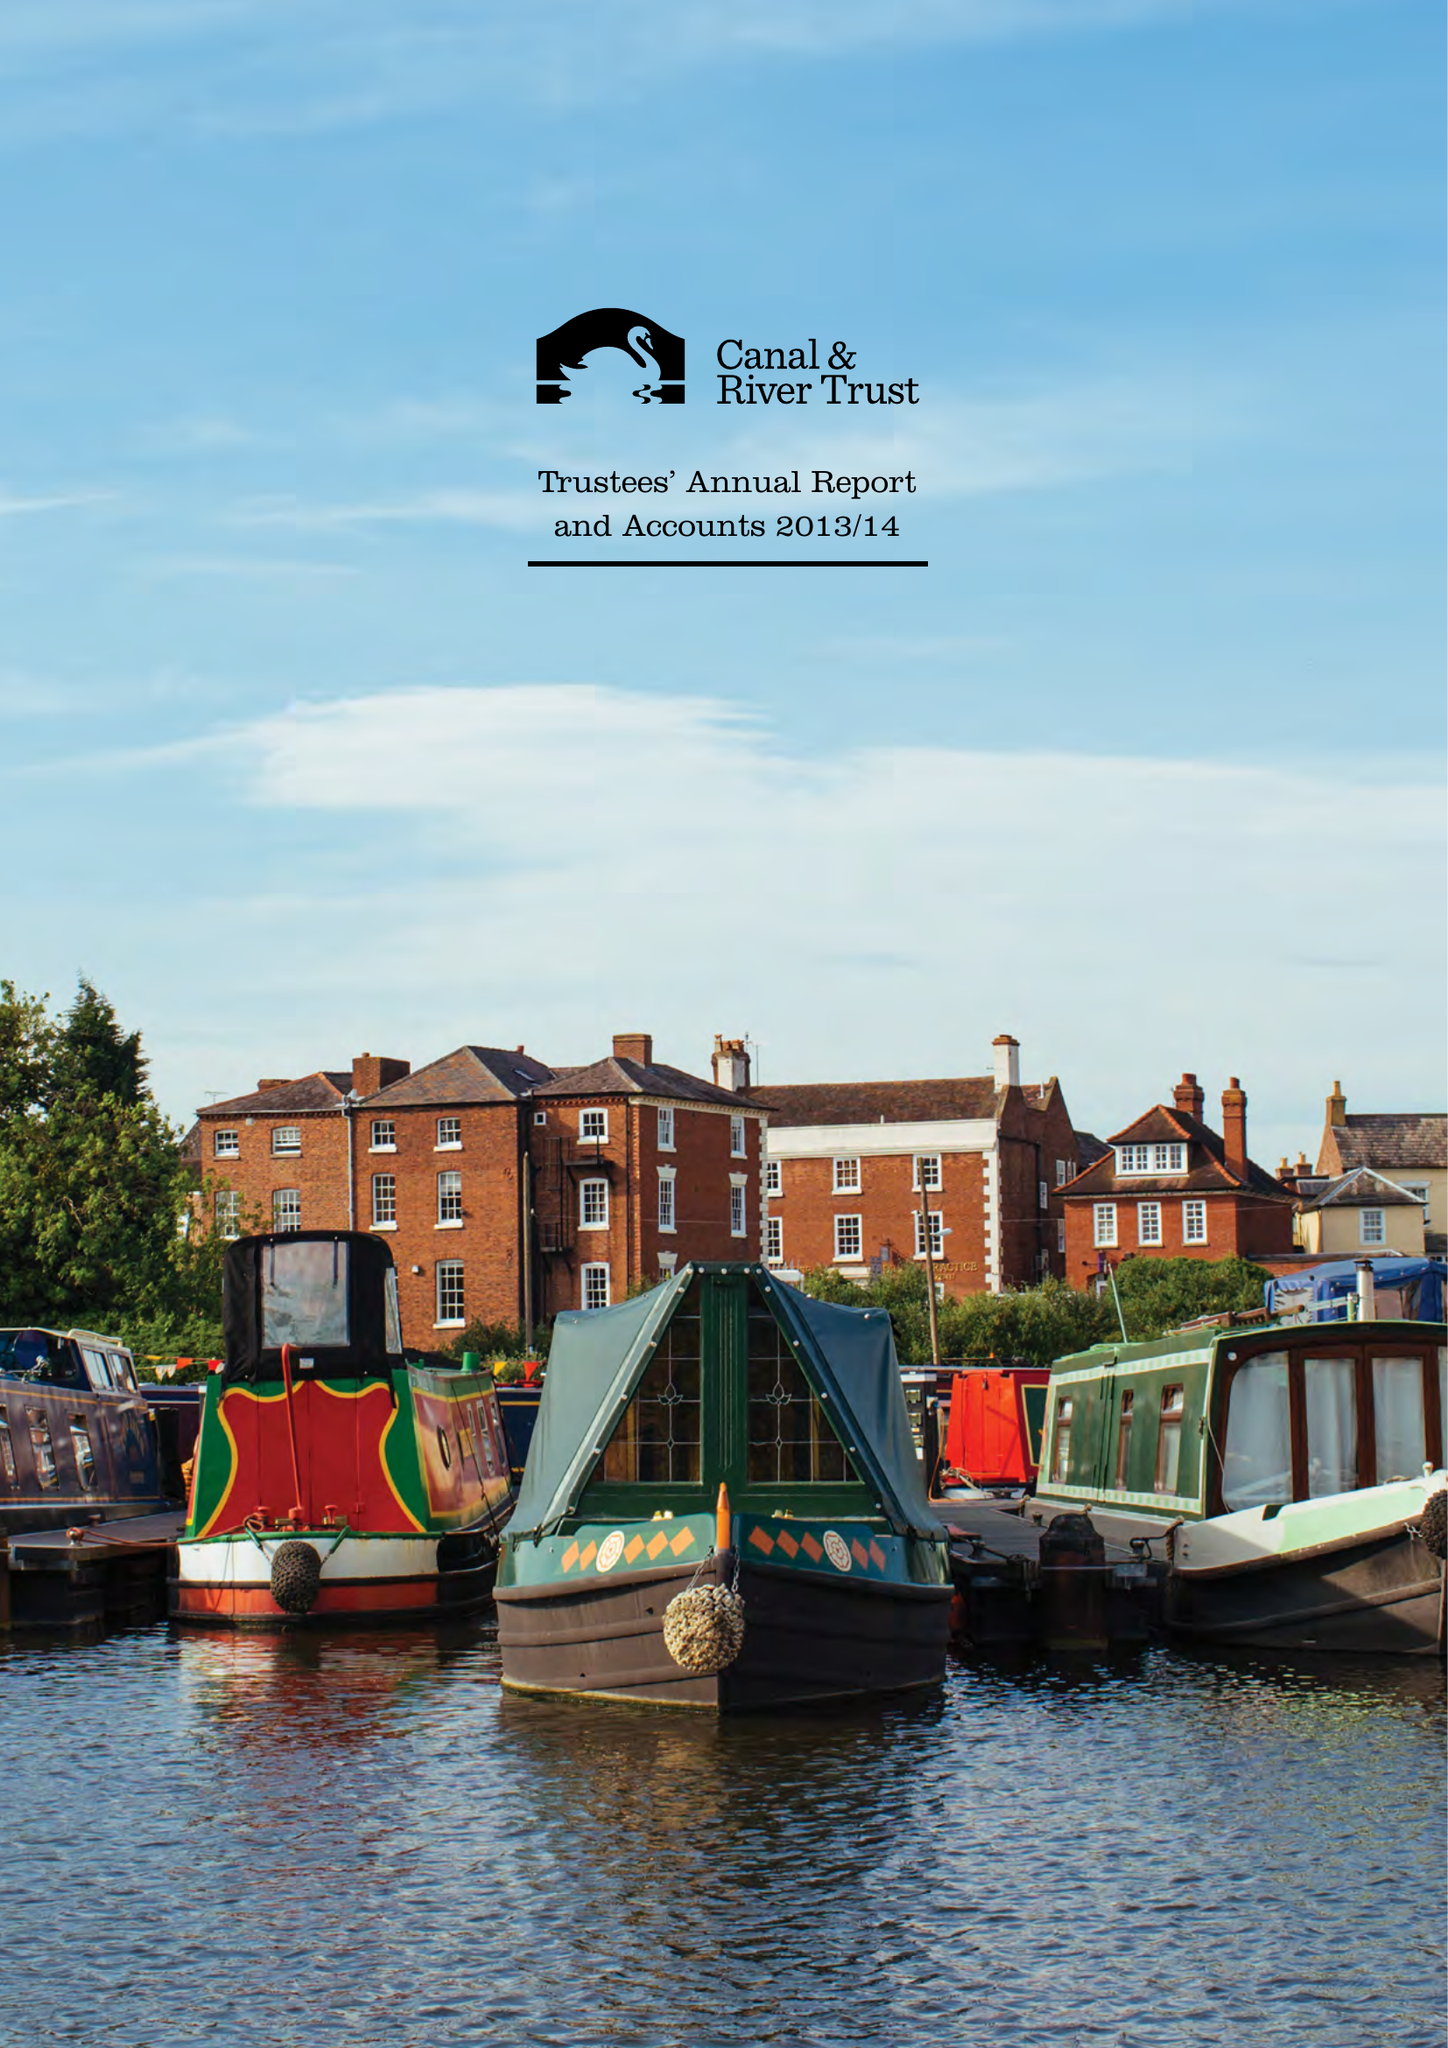What is the value for the spending_annually_in_british_pounds?
Answer the question using a single word or phrase. 156700000.00 